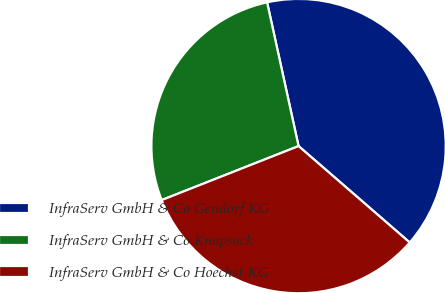Convert chart to OTSL. <chart><loc_0><loc_0><loc_500><loc_500><pie_chart><fcel>InfraServ GmbH & Co Gendorf KG<fcel>InfraServ GmbH & Co Knapsack<fcel>InfraServ GmbH & Co Hoechst KG<nl><fcel>39.8%<fcel>27.55%<fcel>32.65%<nl></chart> 